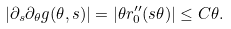<formula> <loc_0><loc_0><loc_500><loc_500>| \partial _ { s } \partial _ { \theta } g ( \theta , s ) | = | \theta r _ { 0 } ^ { \prime \prime } ( s \theta ) | \leq C \theta .</formula> 